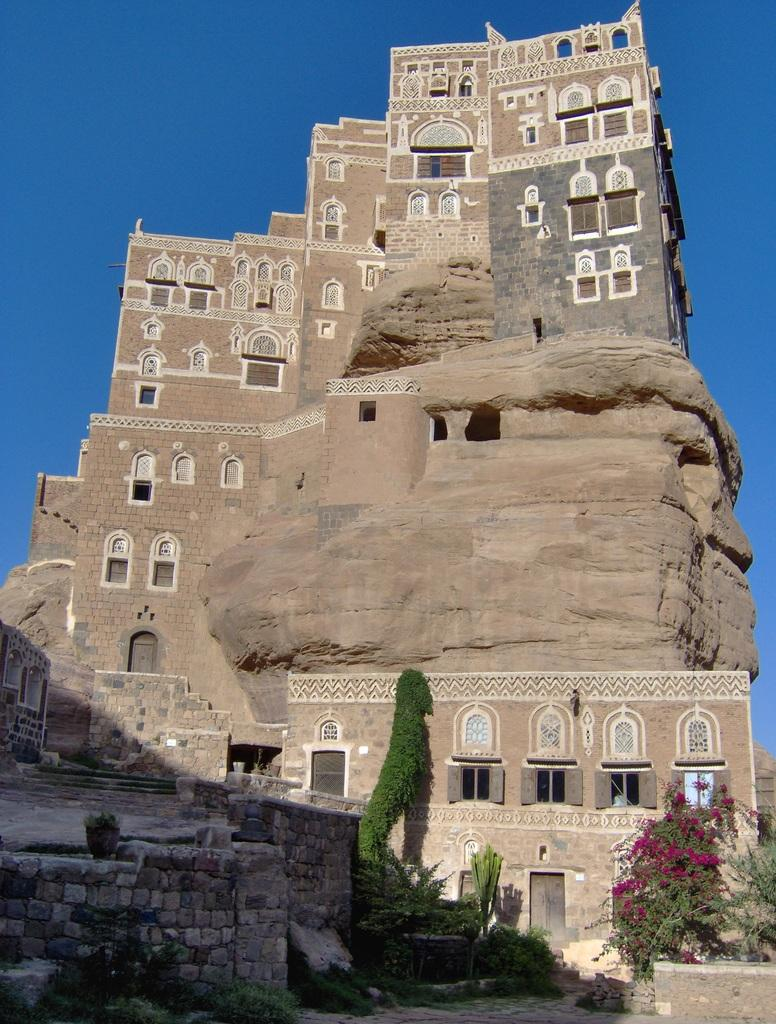What type of structure is in the image? There is a castle in the image. What features can be seen on the castle? The castle has windows and doors. What is located in front of the castle? There are plants in front of the castle. What color is the sky in the image? The sky is blue in color. Can you see a dog playing with a ball near the coast in the image? There is no dog or coast present in the image; it features a castle with plants in front and a blue sky. 